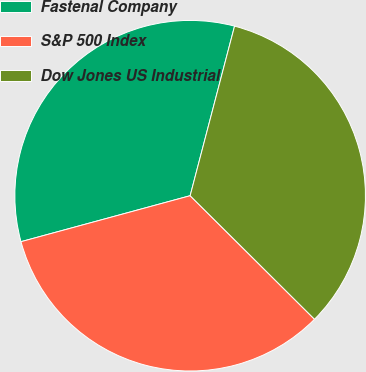Convert chart to OTSL. <chart><loc_0><loc_0><loc_500><loc_500><pie_chart><fcel>Fastenal Company<fcel>S&P 500 Index<fcel>Dow Jones US Industrial<nl><fcel>33.3%<fcel>33.33%<fcel>33.37%<nl></chart> 